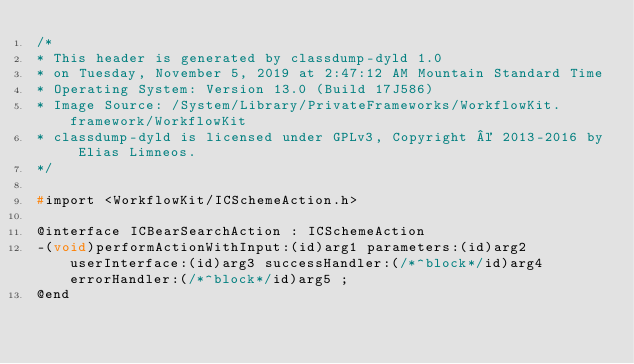Convert code to text. <code><loc_0><loc_0><loc_500><loc_500><_C_>/*
* This header is generated by classdump-dyld 1.0
* on Tuesday, November 5, 2019 at 2:47:12 AM Mountain Standard Time
* Operating System: Version 13.0 (Build 17J586)
* Image Source: /System/Library/PrivateFrameworks/WorkflowKit.framework/WorkflowKit
* classdump-dyld is licensed under GPLv3, Copyright © 2013-2016 by Elias Limneos.
*/

#import <WorkflowKit/ICSchemeAction.h>

@interface ICBearSearchAction : ICSchemeAction
-(void)performActionWithInput:(id)arg1 parameters:(id)arg2 userInterface:(id)arg3 successHandler:(/*^block*/id)arg4 errorHandler:(/*^block*/id)arg5 ;
@end

</code> 